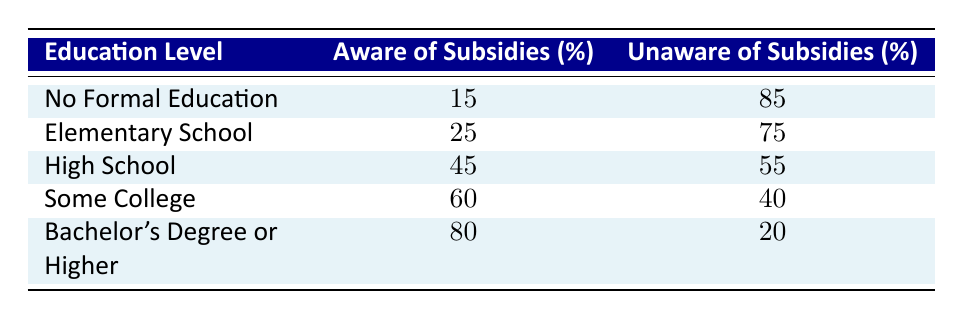What percentage of farmers with a Bachelor's Degree or higher are aware of subsidies? Referring to the table, the percentage of farmers who are aware of subsidies with a Bachelor's Degree or higher is directly listed as 80%.
Answer: 80% What is the percentage of farmers who are unaware of subsidies among those with Some College education? Looking at the table, the row for Some College shows that the percentage of farmers unaware of subsidies is 40%.
Answer: 40% Is it true that the awareness of subsidies increases as education level increases? Analyzing the table, each education level shows a trend where the percentage of awareness increases with higher education levels. For example, it goes from 15% awareness with No Formal Education to 80% with a Bachelor's Degree or higher, confirming that it is true.
Answer: Yes What is the difference in the percentage of farmers who are aware of subsidies between those with No Formal Education and those with High School education? The percentage for No Formal Education is 15%, and for High School, it is 45%. To find the difference, we calculate 45 - 15 = 30%.
Answer: 30% What is the average percentage of awareness of subsidies among all education levels listed? To find the average, we sum all aware percentages (15 + 25 + 45 + 60 + 80 = 225) and divide by the number of education levels (5). The average is 225/5 = 45%.
Answer: 45% How many more percentage points are farmers with a Bachelor's Degree or higher aware of subsidies compared to those with an Elementary School education? The awareness of subsidies for those with a Bachelor's Degree is 80%, and for Elementary School, it is 25%. The difference is calculated as 80 - 25 = 55 percentage points.
Answer: 55 What percentage of farmers with No Formal Education are unaware of subsidies? The table indicates that 85% of farmers with No Formal Education are unaware of subsidies, according to the data listed.
Answer: 85% How does the percentage of awareness among those with Some College compare to those with High School education? According to the table, the percentage for Some College is 60%, while for High School it is 45%. This shows that those with Some College education have 15% higher awareness compared to those with High School.
Answer: 15% 